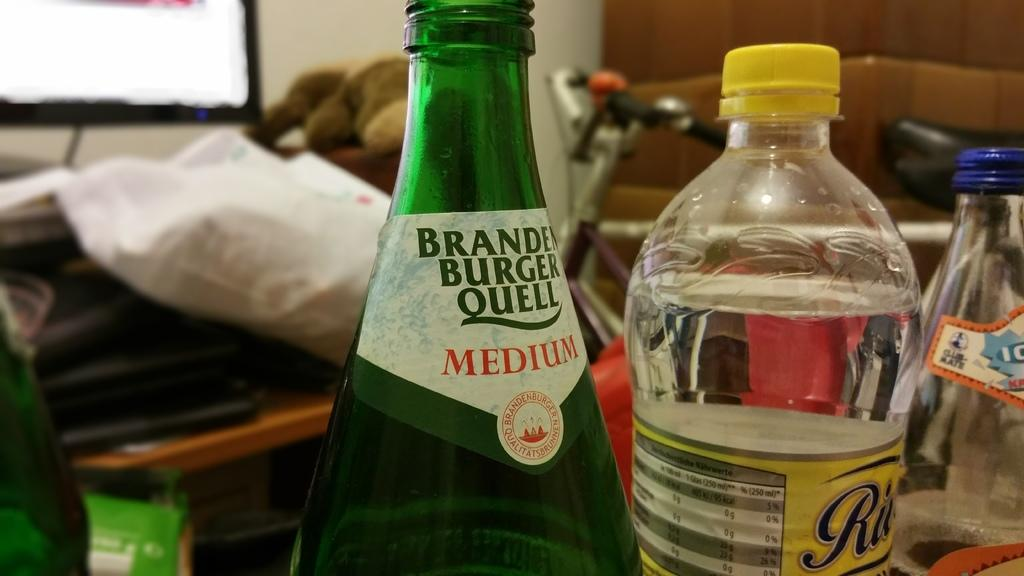Provide a one-sentence caption for the provided image. A medium green glass bottle sits next to a plastic bottle with a yellow cap. 